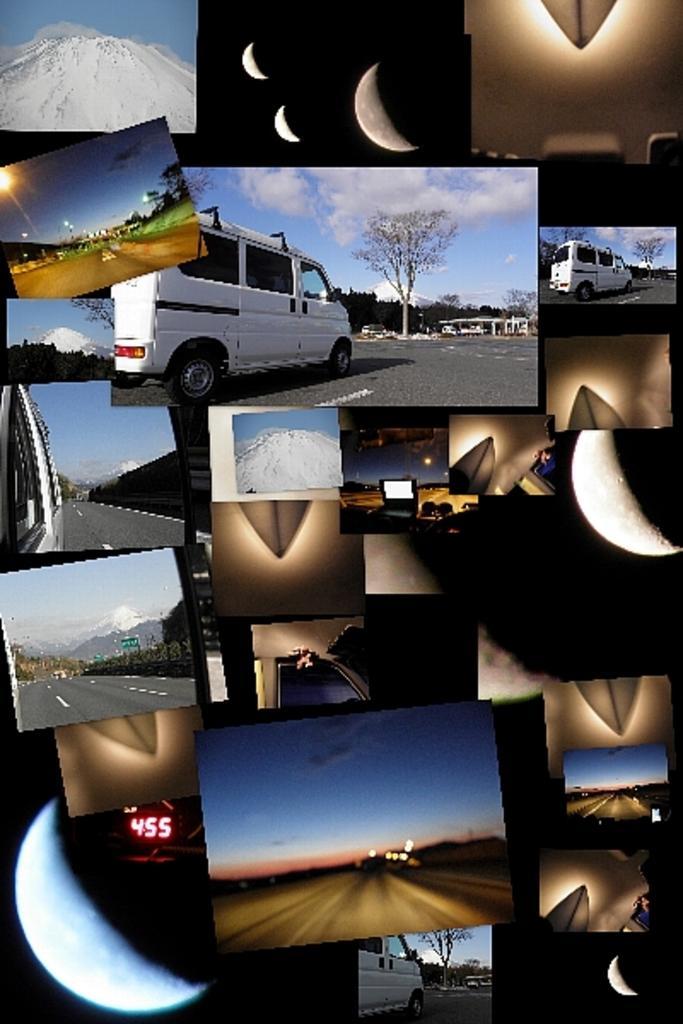In one or two sentences, can you explain what this image depicts? This is a collage image of the few pictures in which we can see roads, vehicles, moon, mountain and trees. 